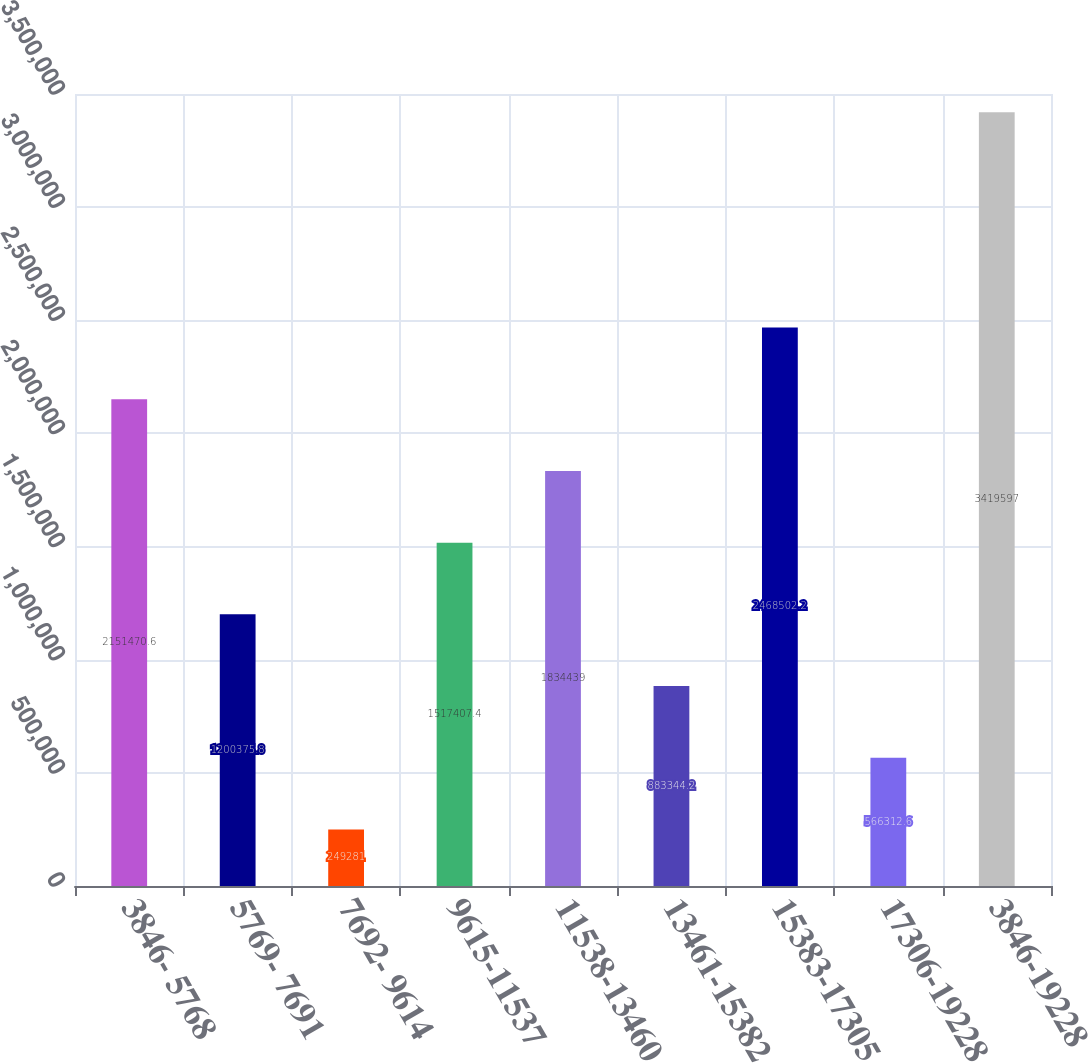<chart> <loc_0><loc_0><loc_500><loc_500><bar_chart><fcel>3846- 5768<fcel>5769- 7691<fcel>7692- 9614<fcel>9615-11537<fcel>11538-13460<fcel>13461-15382<fcel>15383-17305<fcel>17306-19228<fcel>3846-19228<nl><fcel>2.15147e+06<fcel>1.20038e+06<fcel>249281<fcel>1.51741e+06<fcel>1.83444e+06<fcel>883344<fcel>2.4685e+06<fcel>566313<fcel>3.4196e+06<nl></chart> 